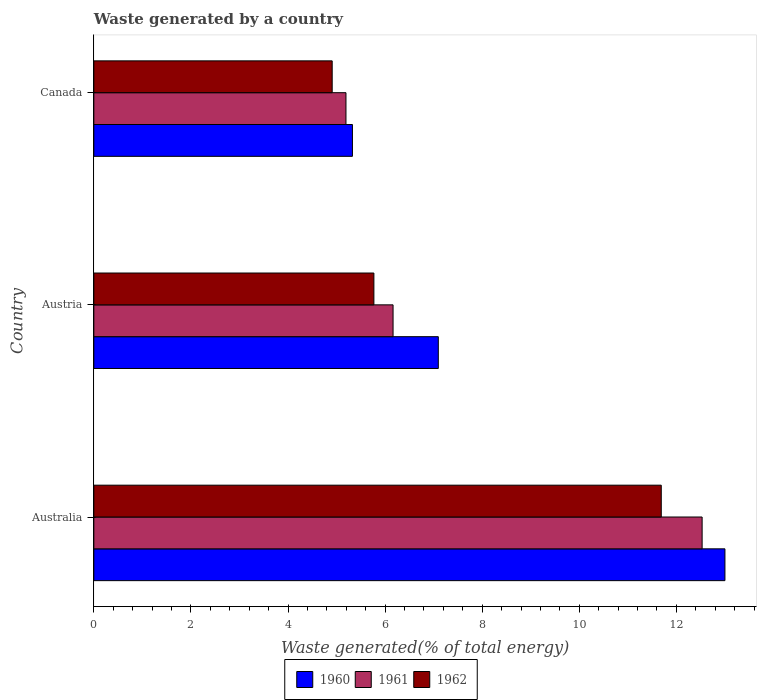How many different coloured bars are there?
Your answer should be compact. 3. How many groups of bars are there?
Offer a very short reply. 3. How many bars are there on the 2nd tick from the bottom?
Provide a succinct answer. 3. What is the label of the 3rd group of bars from the top?
Offer a very short reply. Australia. What is the total waste generated in 1960 in Australia?
Your answer should be very brief. 13. Across all countries, what is the maximum total waste generated in 1960?
Offer a terse response. 13. Across all countries, what is the minimum total waste generated in 1960?
Provide a short and direct response. 5.33. In which country was the total waste generated in 1962 minimum?
Ensure brevity in your answer.  Canada. What is the total total waste generated in 1962 in the graph?
Your response must be concise. 22.37. What is the difference between the total waste generated in 1962 in Australia and that in Austria?
Ensure brevity in your answer.  5.92. What is the difference between the total waste generated in 1961 in Canada and the total waste generated in 1962 in Australia?
Your response must be concise. -6.5. What is the average total waste generated in 1961 per country?
Provide a short and direct response. 7.96. What is the difference between the total waste generated in 1961 and total waste generated in 1960 in Austria?
Give a very brief answer. -0.93. What is the ratio of the total waste generated in 1962 in Austria to that in Canada?
Make the answer very short. 1.17. Is the difference between the total waste generated in 1961 in Australia and Austria greater than the difference between the total waste generated in 1960 in Australia and Austria?
Give a very brief answer. Yes. What is the difference between the highest and the second highest total waste generated in 1960?
Your answer should be compact. 5.9. What is the difference between the highest and the lowest total waste generated in 1960?
Ensure brevity in your answer.  7.67. What does the 1st bar from the top in Canada represents?
Provide a short and direct response. 1962. Is it the case that in every country, the sum of the total waste generated in 1960 and total waste generated in 1962 is greater than the total waste generated in 1961?
Your answer should be very brief. Yes. How many countries are there in the graph?
Your answer should be very brief. 3. Are the values on the major ticks of X-axis written in scientific E-notation?
Your answer should be compact. No. Does the graph contain any zero values?
Your answer should be very brief. No. Where does the legend appear in the graph?
Offer a very short reply. Bottom center. How many legend labels are there?
Keep it short and to the point. 3. What is the title of the graph?
Your answer should be compact. Waste generated by a country. What is the label or title of the X-axis?
Offer a terse response. Waste generated(% of total energy). What is the label or title of the Y-axis?
Provide a short and direct response. Country. What is the Waste generated(% of total energy) in 1960 in Australia?
Make the answer very short. 13. What is the Waste generated(% of total energy) in 1961 in Australia?
Your answer should be very brief. 12.53. What is the Waste generated(% of total energy) in 1962 in Australia?
Offer a terse response. 11.69. What is the Waste generated(% of total energy) of 1960 in Austria?
Keep it short and to the point. 7.1. What is the Waste generated(% of total energy) in 1961 in Austria?
Provide a succinct answer. 6.16. What is the Waste generated(% of total energy) of 1962 in Austria?
Your answer should be compact. 5.77. What is the Waste generated(% of total energy) of 1960 in Canada?
Keep it short and to the point. 5.33. What is the Waste generated(% of total energy) in 1961 in Canada?
Give a very brief answer. 5.19. What is the Waste generated(% of total energy) of 1962 in Canada?
Your answer should be very brief. 4.91. Across all countries, what is the maximum Waste generated(% of total energy) of 1960?
Keep it short and to the point. 13. Across all countries, what is the maximum Waste generated(% of total energy) in 1961?
Ensure brevity in your answer.  12.53. Across all countries, what is the maximum Waste generated(% of total energy) in 1962?
Make the answer very short. 11.69. Across all countries, what is the minimum Waste generated(% of total energy) of 1960?
Your answer should be compact. 5.33. Across all countries, what is the minimum Waste generated(% of total energy) in 1961?
Offer a very short reply. 5.19. Across all countries, what is the minimum Waste generated(% of total energy) of 1962?
Offer a terse response. 4.91. What is the total Waste generated(% of total energy) of 1960 in the graph?
Provide a short and direct response. 25.43. What is the total Waste generated(% of total energy) in 1961 in the graph?
Give a very brief answer. 23.89. What is the total Waste generated(% of total energy) in 1962 in the graph?
Make the answer very short. 22.37. What is the difference between the Waste generated(% of total energy) of 1960 in Australia and that in Austria?
Offer a terse response. 5.9. What is the difference between the Waste generated(% of total energy) in 1961 in Australia and that in Austria?
Ensure brevity in your answer.  6.37. What is the difference between the Waste generated(% of total energy) of 1962 in Australia and that in Austria?
Your response must be concise. 5.92. What is the difference between the Waste generated(% of total energy) in 1960 in Australia and that in Canada?
Ensure brevity in your answer.  7.67. What is the difference between the Waste generated(% of total energy) of 1961 in Australia and that in Canada?
Offer a very short reply. 7.34. What is the difference between the Waste generated(% of total energy) in 1962 in Australia and that in Canada?
Your response must be concise. 6.78. What is the difference between the Waste generated(% of total energy) of 1960 in Austria and that in Canada?
Give a very brief answer. 1.77. What is the difference between the Waste generated(% of total energy) in 1961 in Austria and that in Canada?
Your response must be concise. 0.97. What is the difference between the Waste generated(% of total energy) in 1962 in Austria and that in Canada?
Offer a very short reply. 0.86. What is the difference between the Waste generated(% of total energy) in 1960 in Australia and the Waste generated(% of total energy) in 1961 in Austria?
Provide a short and direct response. 6.84. What is the difference between the Waste generated(% of total energy) in 1960 in Australia and the Waste generated(% of total energy) in 1962 in Austria?
Your response must be concise. 7.23. What is the difference between the Waste generated(% of total energy) in 1961 in Australia and the Waste generated(% of total energy) in 1962 in Austria?
Keep it short and to the point. 6.76. What is the difference between the Waste generated(% of total energy) of 1960 in Australia and the Waste generated(% of total energy) of 1961 in Canada?
Your answer should be compact. 7.81. What is the difference between the Waste generated(% of total energy) in 1960 in Australia and the Waste generated(% of total energy) in 1962 in Canada?
Offer a terse response. 8.09. What is the difference between the Waste generated(% of total energy) of 1961 in Australia and the Waste generated(% of total energy) of 1962 in Canada?
Make the answer very short. 7.62. What is the difference between the Waste generated(% of total energy) of 1960 in Austria and the Waste generated(% of total energy) of 1961 in Canada?
Make the answer very short. 1.9. What is the difference between the Waste generated(% of total energy) in 1960 in Austria and the Waste generated(% of total energy) in 1962 in Canada?
Offer a terse response. 2.19. What is the difference between the Waste generated(% of total energy) in 1961 in Austria and the Waste generated(% of total energy) in 1962 in Canada?
Provide a succinct answer. 1.25. What is the average Waste generated(% of total energy) of 1960 per country?
Your answer should be very brief. 8.48. What is the average Waste generated(% of total energy) of 1961 per country?
Keep it short and to the point. 7.96. What is the average Waste generated(% of total energy) of 1962 per country?
Offer a very short reply. 7.46. What is the difference between the Waste generated(% of total energy) in 1960 and Waste generated(% of total energy) in 1961 in Australia?
Provide a succinct answer. 0.47. What is the difference between the Waste generated(% of total energy) of 1960 and Waste generated(% of total energy) of 1962 in Australia?
Provide a succinct answer. 1.31. What is the difference between the Waste generated(% of total energy) of 1961 and Waste generated(% of total energy) of 1962 in Australia?
Give a very brief answer. 0.84. What is the difference between the Waste generated(% of total energy) in 1960 and Waste generated(% of total energy) in 1961 in Austria?
Keep it short and to the point. 0.93. What is the difference between the Waste generated(% of total energy) of 1960 and Waste generated(% of total energy) of 1962 in Austria?
Provide a short and direct response. 1.33. What is the difference between the Waste generated(% of total energy) in 1961 and Waste generated(% of total energy) in 1962 in Austria?
Keep it short and to the point. 0.4. What is the difference between the Waste generated(% of total energy) of 1960 and Waste generated(% of total energy) of 1961 in Canada?
Ensure brevity in your answer.  0.13. What is the difference between the Waste generated(% of total energy) of 1960 and Waste generated(% of total energy) of 1962 in Canada?
Make the answer very short. 0.42. What is the difference between the Waste generated(% of total energy) in 1961 and Waste generated(% of total energy) in 1962 in Canada?
Offer a very short reply. 0.28. What is the ratio of the Waste generated(% of total energy) in 1960 in Australia to that in Austria?
Your response must be concise. 1.83. What is the ratio of the Waste generated(% of total energy) of 1961 in Australia to that in Austria?
Make the answer very short. 2.03. What is the ratio of the Waste generated(% of total energy) in 1962 in Australia to that in Austria?
Offer a terse response. 2.03. What is the ratio of the Waste generated(% of total energy) of 1960 in Australia to that in Canada?
Provide a short and direct response. 2.44. What is the ratio of the Waste generated(% of total energy) in 1961 in Australia to that in Canada?
Provide a succinct answer. 2.41. What is the ratio of the Waste generated(% of total energy) of 1962 in Australia to that in Canada?
Provide a succinct answer. 2.38. What is the ratio of the Waste generated(% of total energy) of 1960 in Austria to that in Canada?
Make the answer very short. 1.33. What is the ratio of the Waste generated(% of total energy) in 1961 in Austria to that in Canada?
Keep it short and to the point. 1.19. What is the ratio of the Waste generated(% of total energy) of 1962 in Austria to that in Canada?
Provide a succinct answer. 1.17. What is the difference between the highest and the second highest Waste generated(% of total energy) of 1960?
Give a very brief answer. 5.9. What is the difference between the highest and the second highest Waste generated(% of total energy) in 1961?
Your answer should be compact. 6.37. What is the difference between the highest and the second highest Waste generated(% of total energy) in 1962?
Make the answer very short. 5.92. What is the difference between the highest and the lowest Waste generated(% of total energy) of 1960?
Provide a short and direct response. 7.67. What is the difference between the highest and the lowest Waste generated(% of total energy) in 1961?
Your answer should be very brief. 7.34. What is the difference between the highest and the lowest Waste generated(% of total energy) in 1962?
Your response must be concise. 6.78. 